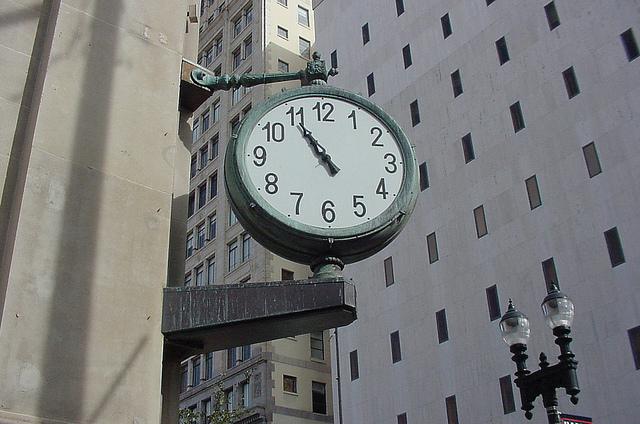What type of numbers are on the clock?
Write a very short answer. Regular. What time is it in this picture?
Quick response, please. 11:55. What is the condition of the building behind the clock?
Write a very short answer. Good. What time does the clock have?
Be succinct. 10:54. Is the clock in Roman numerals?
Keep it brief. No. Is that time correct?
Quick response, please. Yes. What time is shown on the clock?
Give a very brief answer. 10:55. Does the clock have a second hand?
Write a very short answer. No. What time is displayed?
Short answer required. 10:55. What is the time?
Be succinct. 10:55. What time does this clock say?
Short answer required. 10:55. Why is the clock's out metal covering green?
Write a very short answer. Oxidation. What time is it?
Short answer required. 10:55. What time is it on this clock?
Give a very brief answer. 10:55. Is the clock old?
Answer briefly. Yes. What time does the clock say?
Concise answer only. 10:55. 